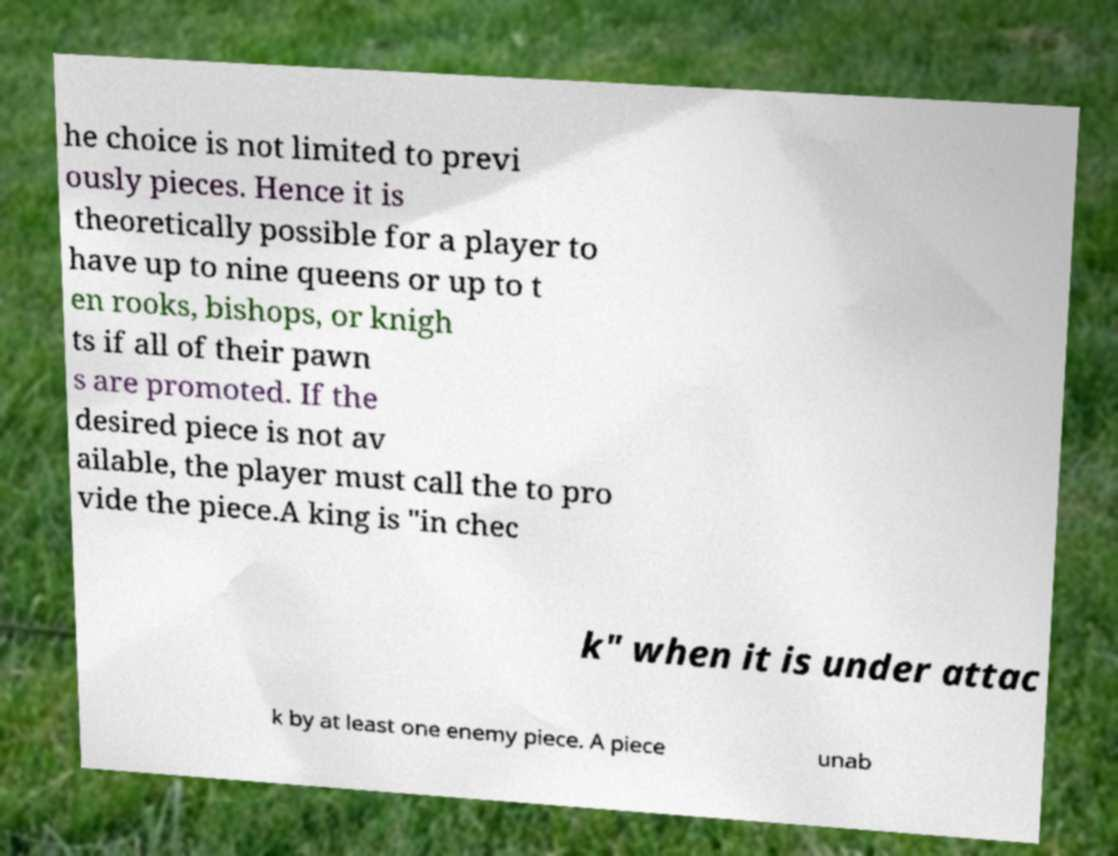Could you extract and type out the text from this image? he choice is not limited to previ ously pieces. Hence it is theoretically possible for a player to have up to nine queens or up to t en rooks, bishops, or knigh ts if all of their pawn s are promoted. If the desired piece is not av ailable, the player must call the to pro vide the piece.A king is "in chec k" when it is under attac k by at least one enemy piece. A piece unab 